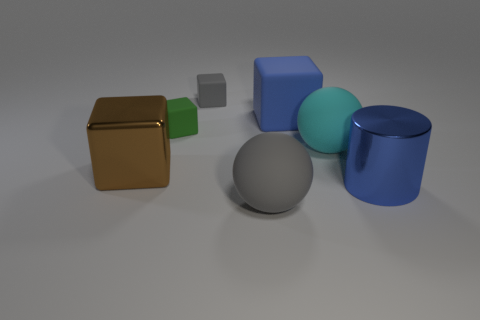How many metal objects are tiny gray blocks or big cyan spheres?
Ensure brevity in your answer.  0. There is a gray thing in front of the small green rubber object; how many big gray matte balls are in front of it?
Give a very brief answer. 0. There is a block that is the same color as the cylinder; what is its size?
Your answer should be very brief. Large. How many things are large green cubes or big blue things on the right side of the blue rubber object?
Ensure brevity in your answer.  1. Is there a block that has the same material as the tiny gray object?
Make the answer very short. Yes. How many things are both right of the brown object and in front of the big cyan ball?
Offer a terse response. 2. There is a brown cube in front of the blue matte object; what material is it?
Your response must be concise. Metal. What is the size of the green block that is made of the same material as the gray block?
Offer a very short reply. Small. There is a blue block; are there any small gray cubes to the right of it?
Make the answer very short. No. There is a gray thing that is the same shape as the tiny green rubber thing; what size is it?
Your answer should be very brief. Small. 